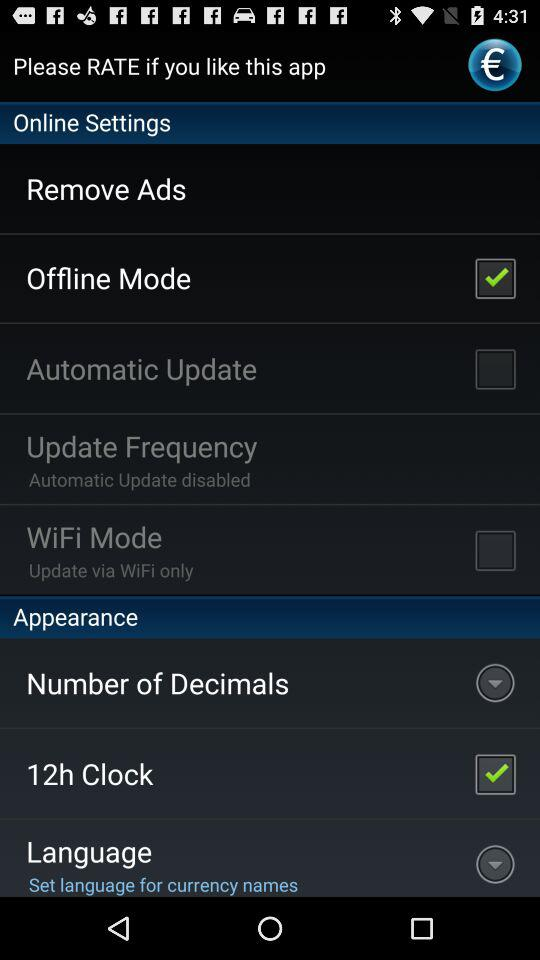What's the clock-hour system? The clock-hour system is 12 hours. 